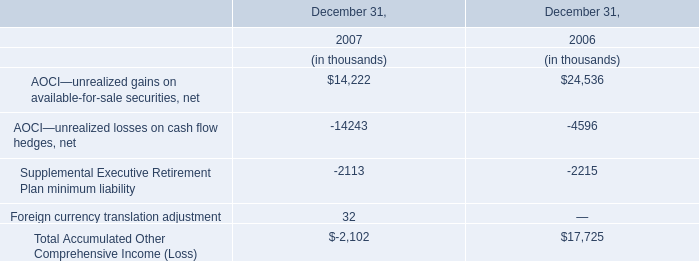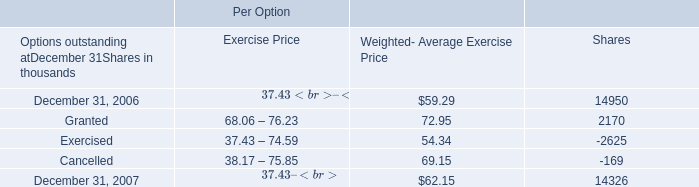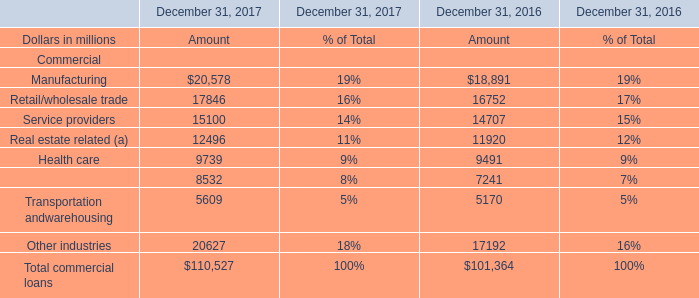what's the total amount of Service providers of December 31, 2017 Amount, Granted of Per Option Shares, and Total commercial loans of December 31, 2016 Amount ? 
Computations: ((15100.0 + 2170.0) + 101364.0)
Answer: 118634.0. 